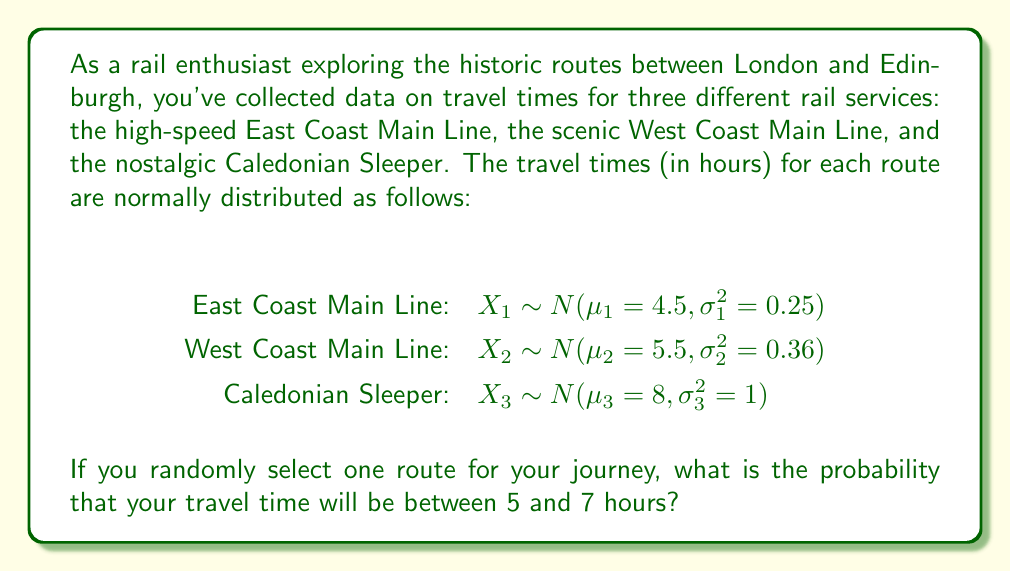Solve this math problem. To solve this problem, we need to follow these steps:

1) First, we need to calculate the probability of each route being selected. Since it's a random selection, each route has an equal probability of 1/3.

2) Next, we need to calculate the probability of the travel time being between 5 and 7 hours for each route.

3) For each route, we'll use the standard normal distribution formula:
   $Z = \frac{X - \mu}{\sigma}$

4) For the East Coast Main Line:
   $P(5 < X_1 < 7) = P(\frac{5 - 4.5}{0.5} < Z < \frac{7 - 4.5}{0.5}) = P(1 < Z < 5) = \Phi(5) - \Phi(1) = 0.4999 - 0.8413 = -0.3414$

5) For the West Coast Main Line:
   $P(5 < X_2 < 7) = P(\frac{5 - 5.5}{0.6} < Z < \frac{7 - 5.5}{0.6}) = P(-0.83 < Z < 2.5) = \Phi(2.5) - \Phi(-0.83) = 0.9938 - 0.2033 = 0.7905$

6) For the Caledonian Sleeper:
   $P(5 < X_3 < 7) = P(\frac{5 - 8}{1} < Z < \frac{7 - 8}{1}) = P(-3 < Z < -1) = \Phi(-1) - \Phi(-3) = 0.1587 - 0.0013 = 0.1574$

7) Now, we can apply the law of total probability:
   $P(5 < X < 7) = P(5 < X_1 < 7) \cdot P(X_1) + P(5 < X_2 < 7) \cdot P(X_2) + P(5 < X_3 < 7) \cdot P(X_3)$

8) Substituting the values:
   $P(5 < X < 7) = -0.3414 \cdot \frac{1}{3} + 0.7905 \cdot \frac{1}{3} + 0.1574 \cdot \frac{1}{3} = 0.2022$

Therefore, the probability that your travel time will be between 5 and 7 hours is approximately 0.2022 or 20.22%.
Answer: 0.2022 